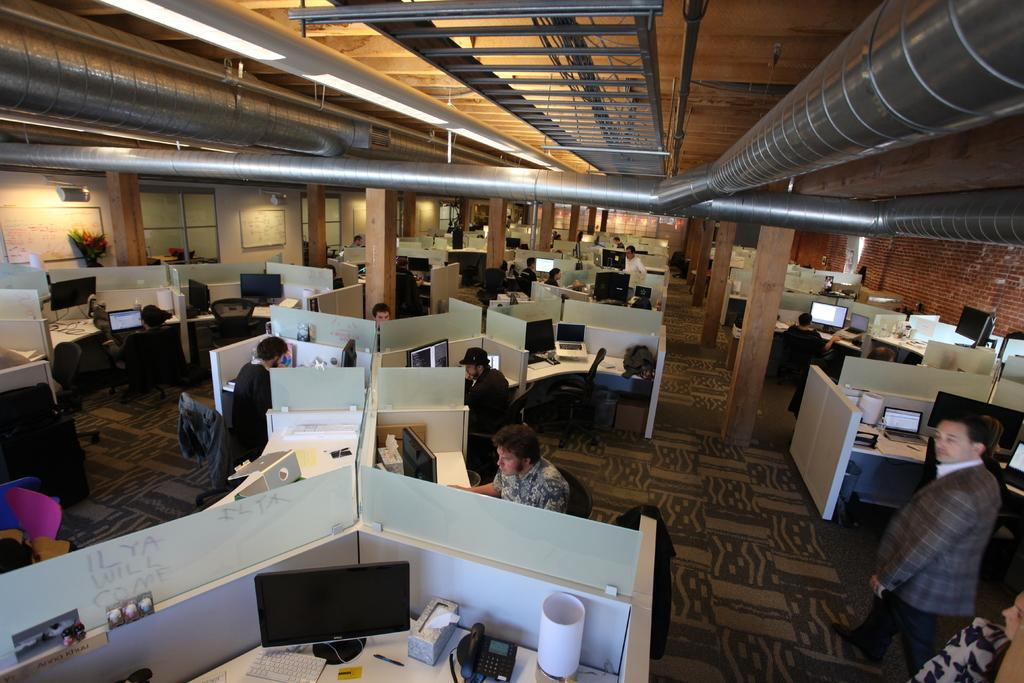Who or what can be seen in the image? There are people in the image. What objects are present in the image that the people might be using? There are desks and computers on every desk in the image. Can you describe any unique features of the room or space in the image? There is a pipeline visible on the ceiling. What type of whip is being used by the person in the image? There is no whip present in the image. Can you tell me the time on the clock in the image? There is no clock present in the image. 